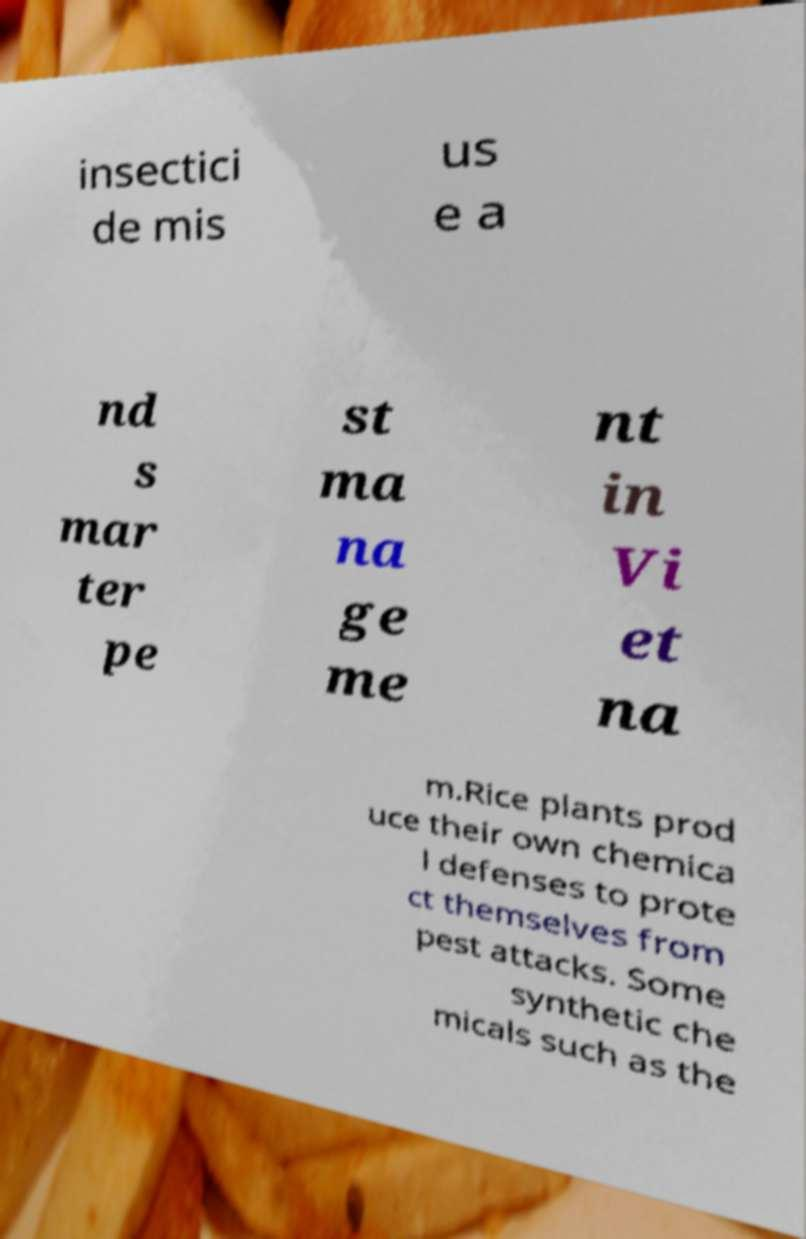Can you accurately transcribe the text from the provided image for me? insectici de mis us e a nd s mar ter pe st ma na ge me nt in Vi et na m.Rice plants prod uce their own chemica l defenses to prote ct themselves from pest attacks. Some synthetic che micals such as the 